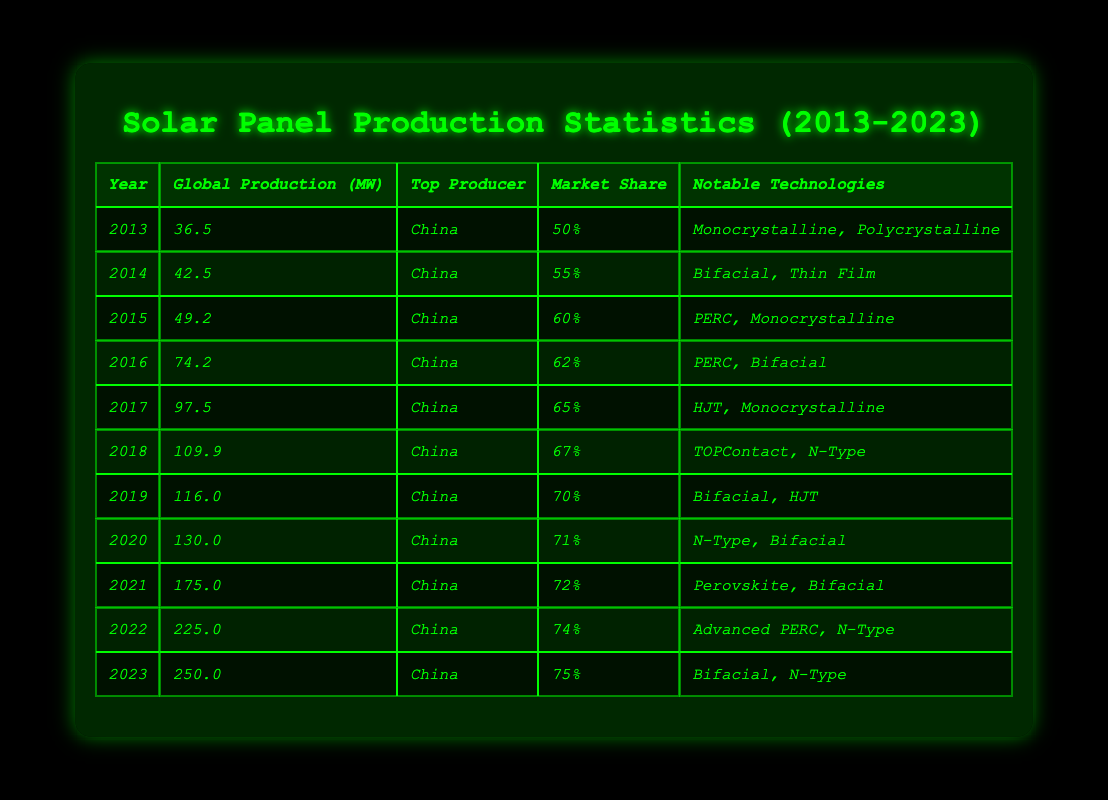What was the global production of solar panels in 2016? According to the table, the global production in 2016 is listed as 74.2 MW.
Answer: 74.2 MW Who was the top producer of solar panels every year from 2013 to 2023? The table shows that China was the top producer for all years listed, from 2013 to 2023.
Answer: China What was the percentage increase in global production from 2013 to 2023? The production in 2013 was 36.5 MW and in 2023 it was 250.0 MW. The increase is 250.0 - 36.5 = 213.5 MW. The percentage increase is (213.5 / 36.5) * 100 ≈ 585.7%.
Answer: 585.7% In which year did the market share for solar panel production exceed 70%? The table shows that market share exceeded 70% starting in 2019, where it reached 70% and continued to rise to 72% by 2021 and 75% by 2023.
Answer: 2019 What is the average global production of solar panels for the years 2019 to 2022? The global production values for these years are 116.0 MW (2019), 130.0 MW (2020), 175.0 MW (2021), and 225.0 MW (2022). Adding these values gives 116.0 + 130.0 + 175.0 + 225.0 = 646.0 MW. Dividing by 4 (the number of years) gives 646.0 / 4 = 161.5 MW.
Answer: 161.5 MW Did the market share increase every year from 2013 to 2023? By examining the data in the table, it shows that market share increased every year: from 50% in 2013 to 75% in 2023, with no decreases in between.
Answer: Yes What notable technology was focused on in 2021? The table indicates that the notable technologies listed for 2021 were "Perovskite, Bifacial."
Answer: Perovskite, Bifacial How much more solar power was produced in 2023 compared to 2015? The global production in 2023 was 250.0 MW and in 2015 it was 49.2 MW. The difference is 250.0 - 49.2 = 200.8 MW.
Answer: 200.8 MW Was there any year in which the global production was less than 50 MW? Referring to the table, only the years 2013 (36.5 MW) and 2014 (42.5 MW) had production values less than 50 MW.
Answer: Yes What was the highest market share recorded during the decade? The market share values are listed, and the highest recorded was 75% in 2023.
Answer: 75% What was the total global production from 2013 to 2014 combined? Adding the global production from 2013 (36.5 MW) and 2014 (42.5 MW) gives a total of 36.5 + 42.5 = 79.0 MW.
Answer: 79.0 MW 